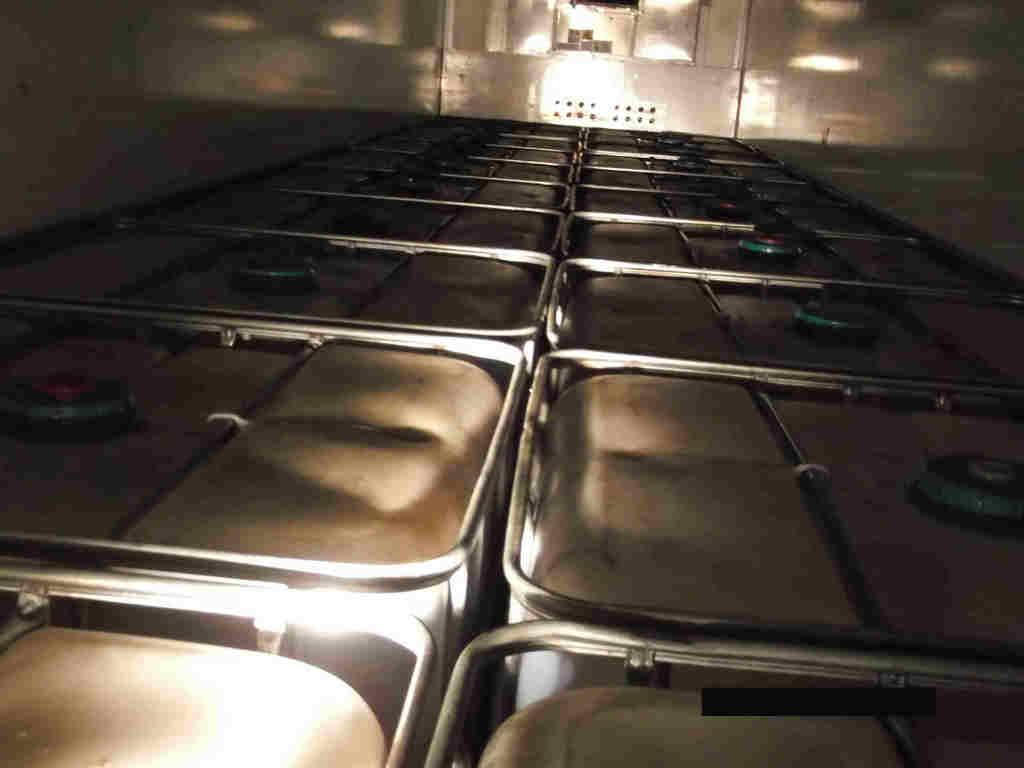What is the main subject of the image? The main subject of the image is many boxes. What type of structure can be seen in the image? There are walls visible in the image. Can you describe the lighting in the image? There is a light source in the image. What type of trousers is the cook wearing in the image? There is no cook or trousers present in the image; it only features many boxes and walls with a light source. 